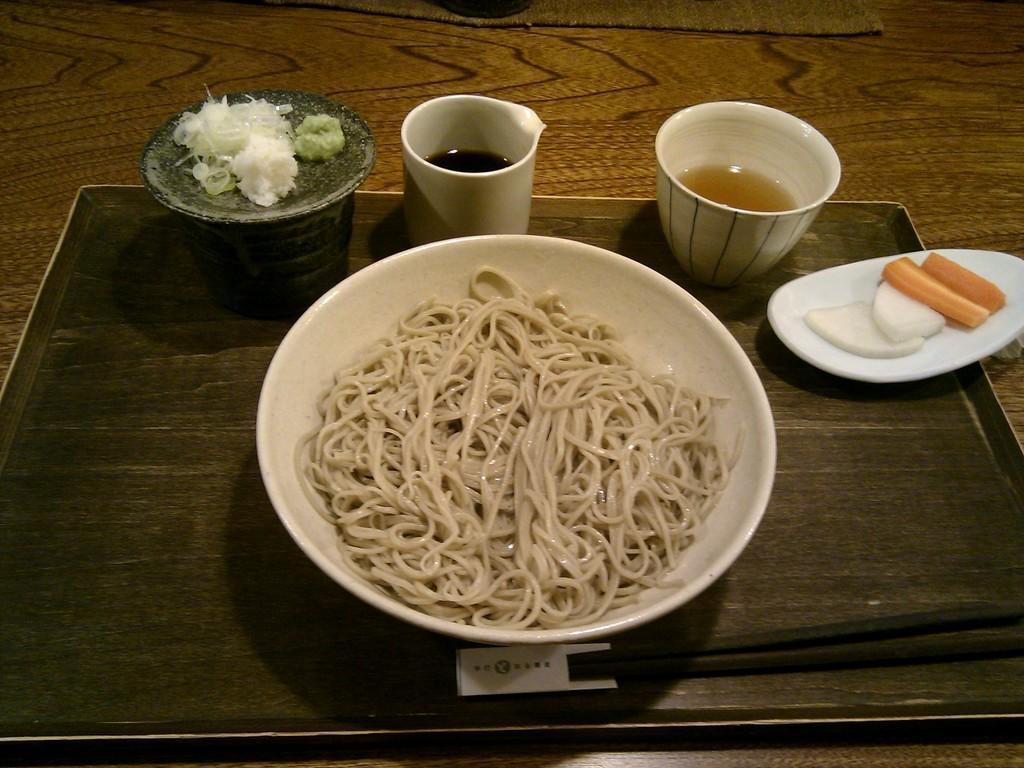How would you summarize this image in a sentence or two? In this image I can see a brown colored table and on it I can see a black colored tray. On the tray I can see a glass with liquid in it, a bowl with brown colored liquid in it, a bowl with noodles in it and a black colored object with a food item which is white and green in color on it. I can see a white colored plate with onion and carrot pieces on it. 